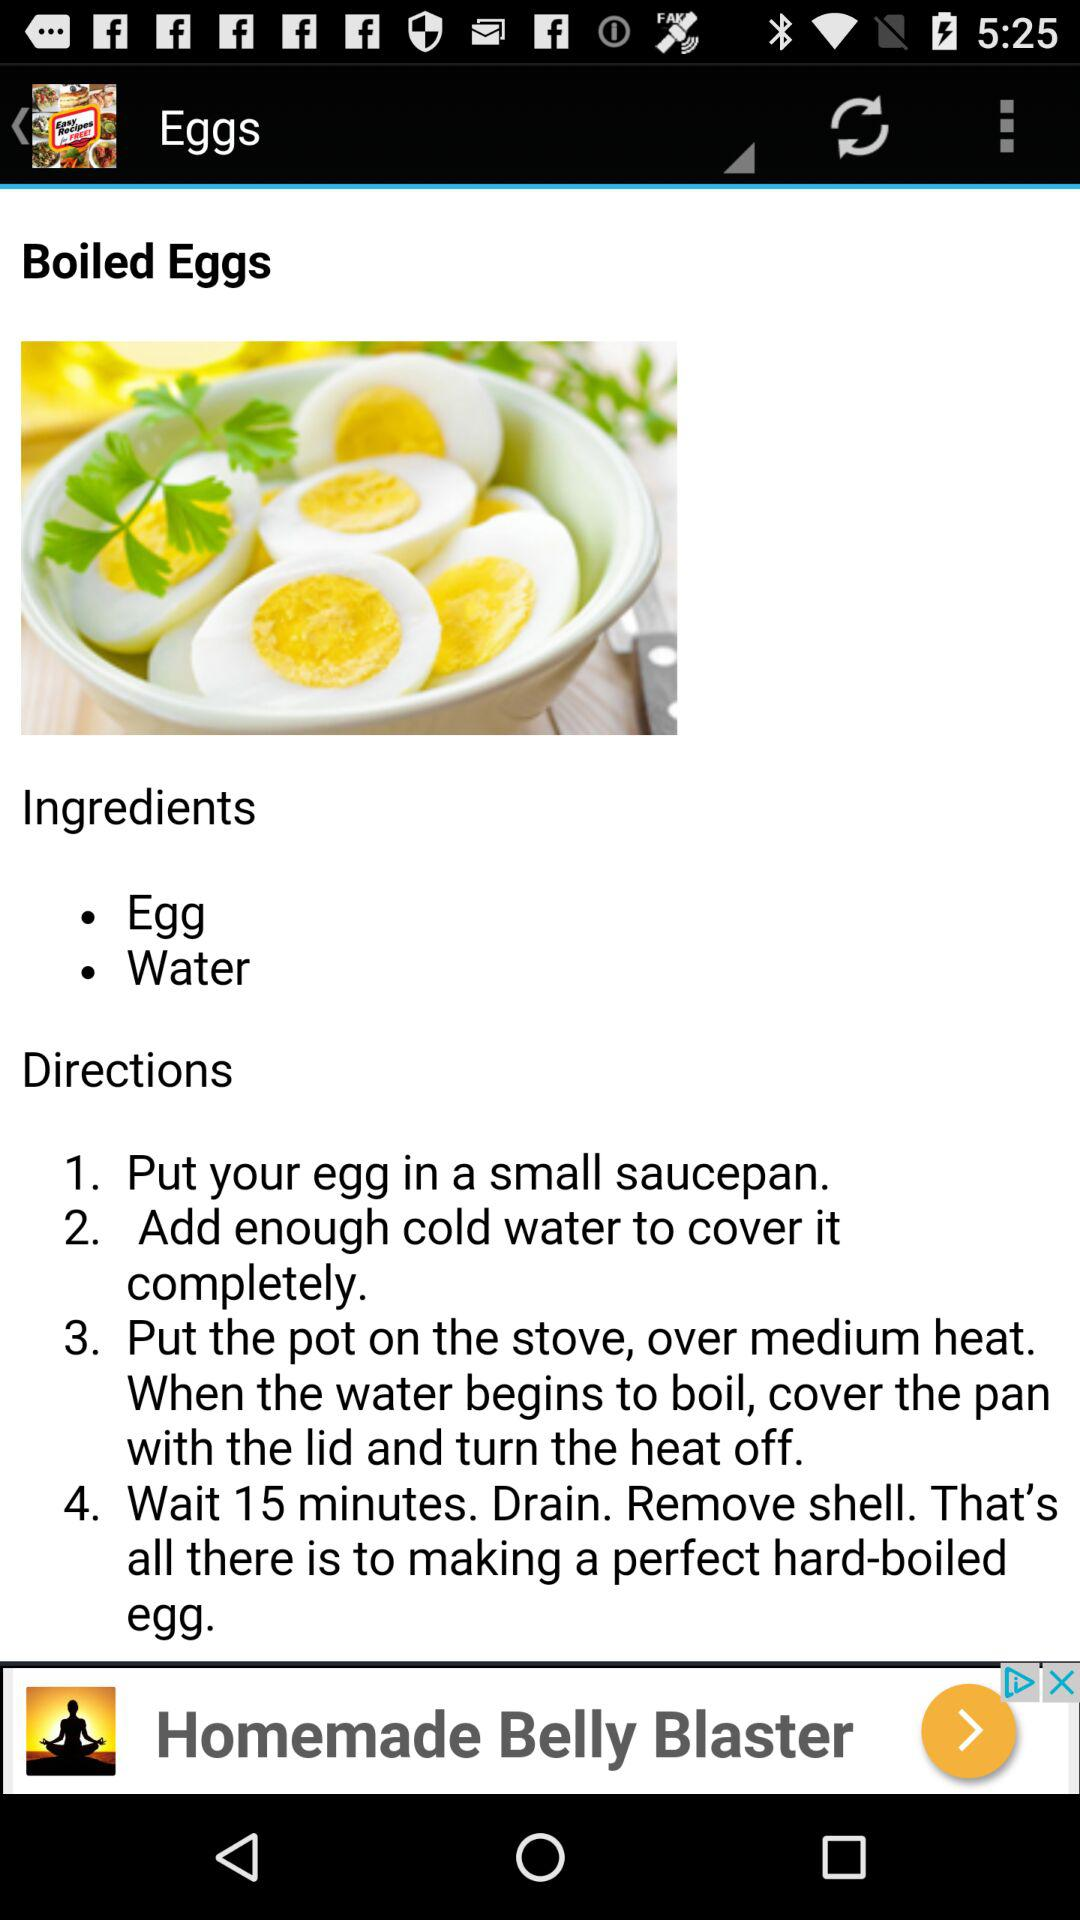What is the recipe? The recipe is "Put your egg in a small saucepan", "Add enough cold water to cover it completely", "Put the pot on the stove, over medium heat. When the water begins to boil, cover the pan with the lid and turn the heat off" and "Wait 15 minutes. Drain. Remove shell. That's all there is to making a perfect hard-boiled egg". 